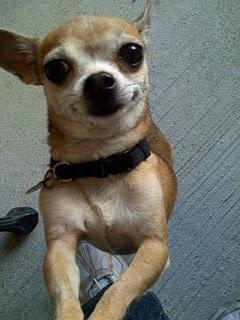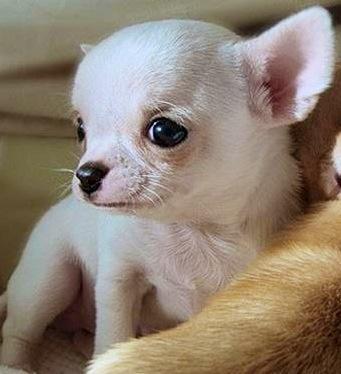The first image is the image on the left, the second image is the image on the right. Assess this claim about the two images: "The dog in the image on the left is wearing a collar.". Correct or not? Answer yes or no. Yes. The first image is the image on the left, the second image is the image on the right. Examine the images to the left and right. Is the description "One dog is wearing the kind of item people wear." accurate? Answer yes or no. No. 